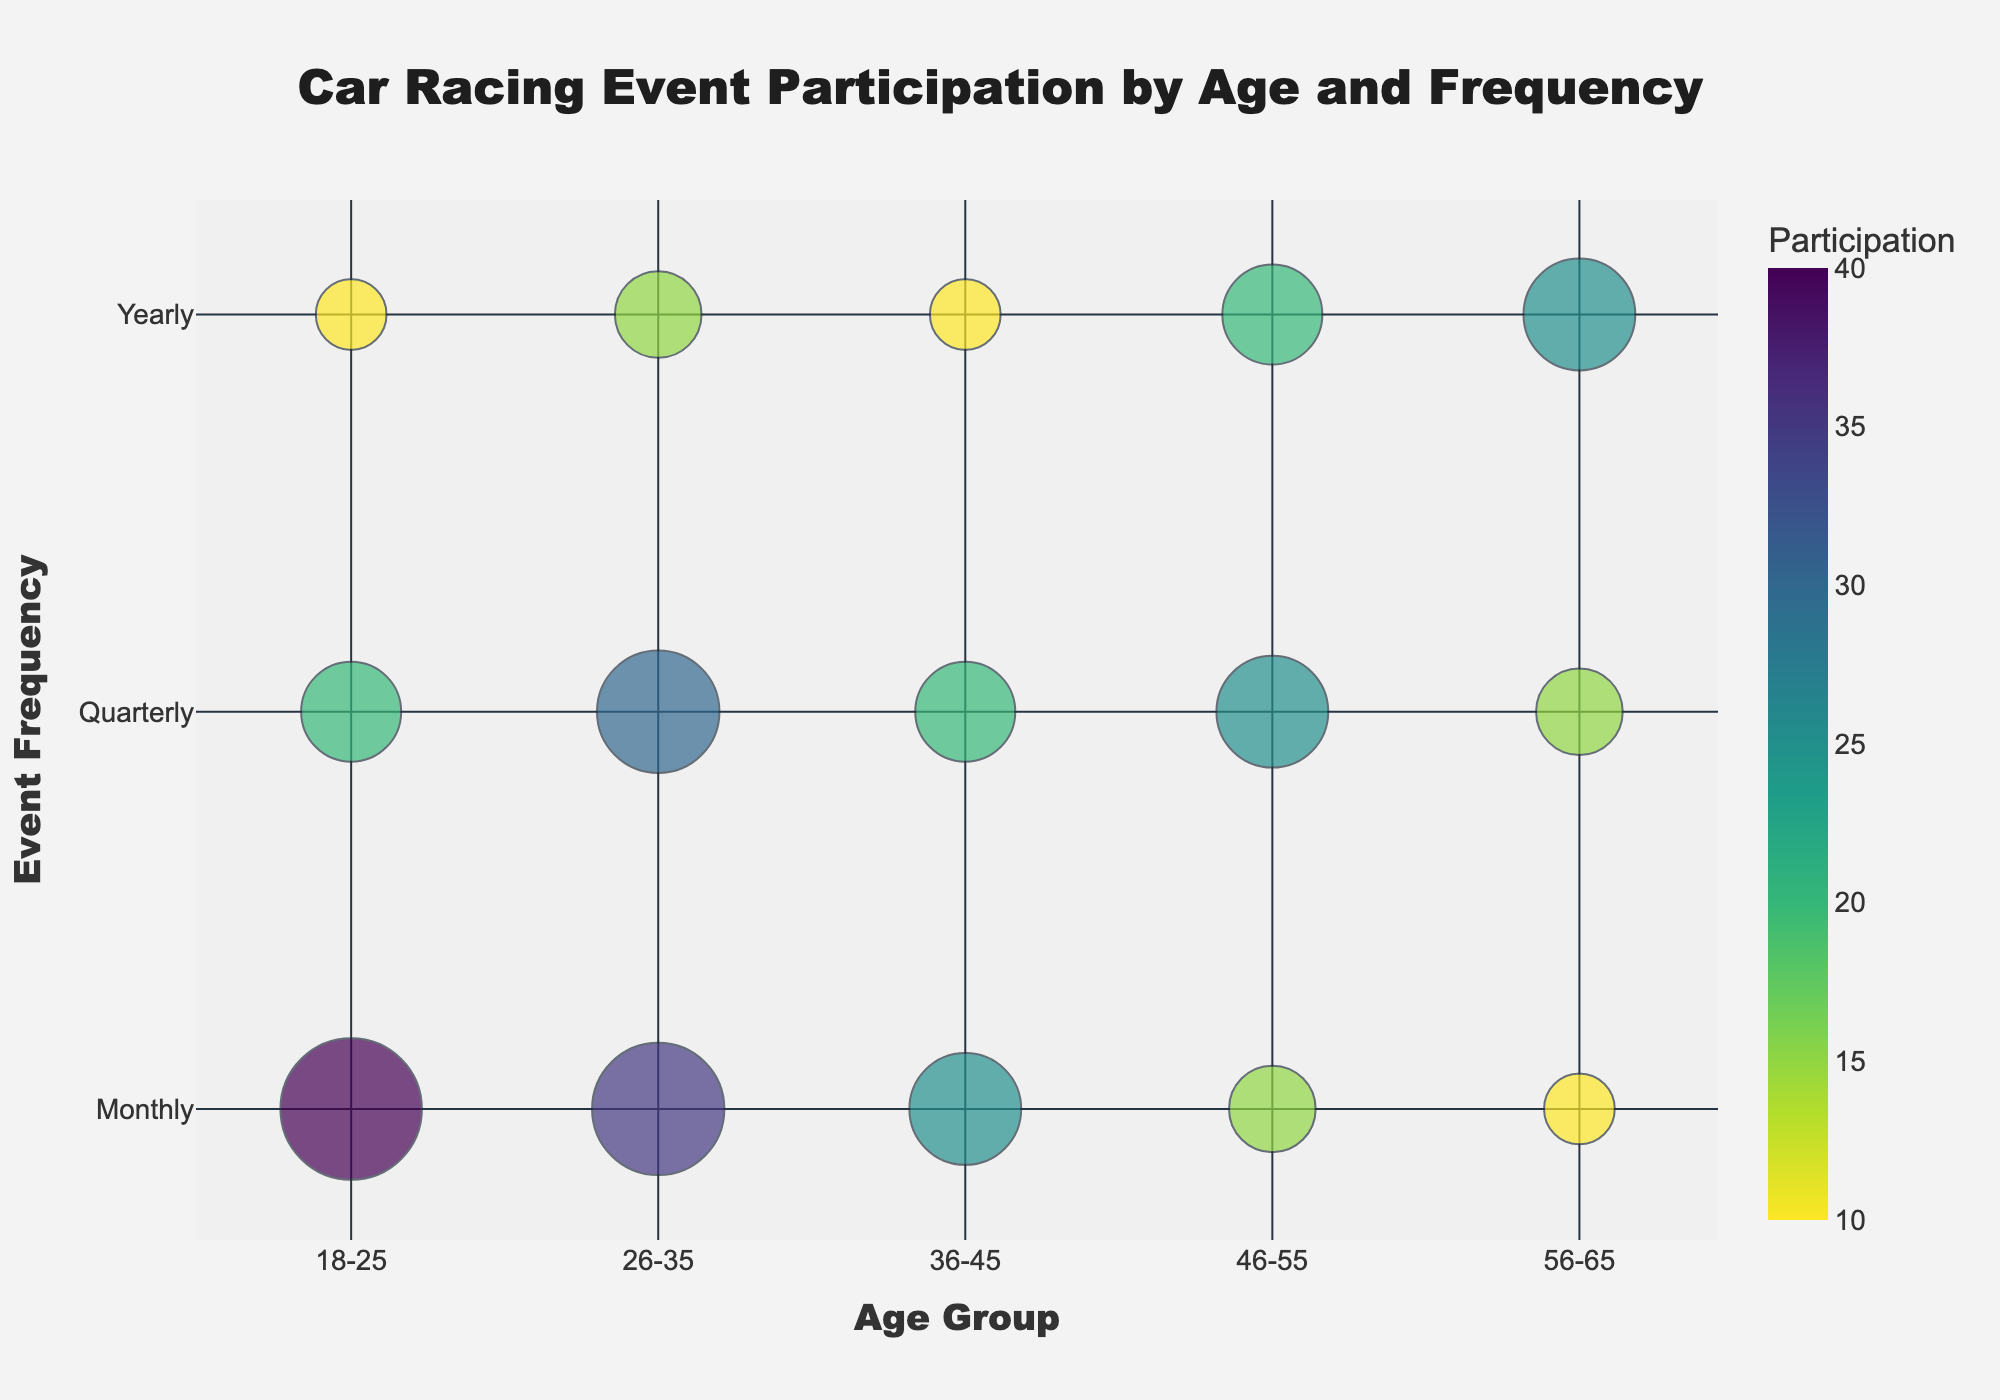What is the title of the chart? The title is usually displayed at the top of the chart. In this case, the title text is specified as "Car Racing Event Participation by Age and Frequency".
Answer: Car Racing Event Participation by Age and Frequency Which age group has the largest participation for monthly events? By examining the sizes of the bubbles along the "Monthly" axis, we find that the largest bubble corresponds to the "18-25" age group.
Answer: 18-25 What is the total participation for yearly events in the 26-35 age group? Check the yearly bubble for the 26-35 age group. The participation value for yearly events is 15.
Answer: 15 How does participation change with age for quarterly events? It involves comparing the bubble sizes for quarterly events across age groups. Participation starts at 20 for 18-25, increases to 30 for 26-35, then drops to 20 for 36-45, another increase to 25 for 46-55, and finally drops to 15 for 56-65.
Answer: Fluctuates Which event frequency has the highest participation overall? Compare the bubble sizes for each event frequency across all age groups. Monthly events generally have the largest bubbles, indicating higher participation.
Answer: Monthly Compare the participation for quarterly events between the 46-55 and 56-65 age groups. Locate the bubbles for quarterly events in these age groups. The 46-55 age group has a participation of 25, while the 56-65 age group has 15.
Answer: 46-55 has higher participation Which age group shows a decline in participation from quarterly to yearly events? For each age group, compare the size of the bubbles from quarterly to yearly events. For the 26-35 age group, the participation decreases from 30 (quarterly) to 15 (yearly).
Answer: 26-35 What is the median participation for the 36-45 age group across all event frequencies? The participation values for the 36-45 age group (25 for monthly, 20 for quarterly, 10 for yearly) need to be ordered (10, 20, 25). The median is the middle value, which is 20.
Answer: 20 Which age group has the smallest participation for monthly events? Examine the smallest bubble along the "Monthly" axis. The smallest bubble corresponds to the "56-65" age group with a value of 10.
Answer: 56-65 